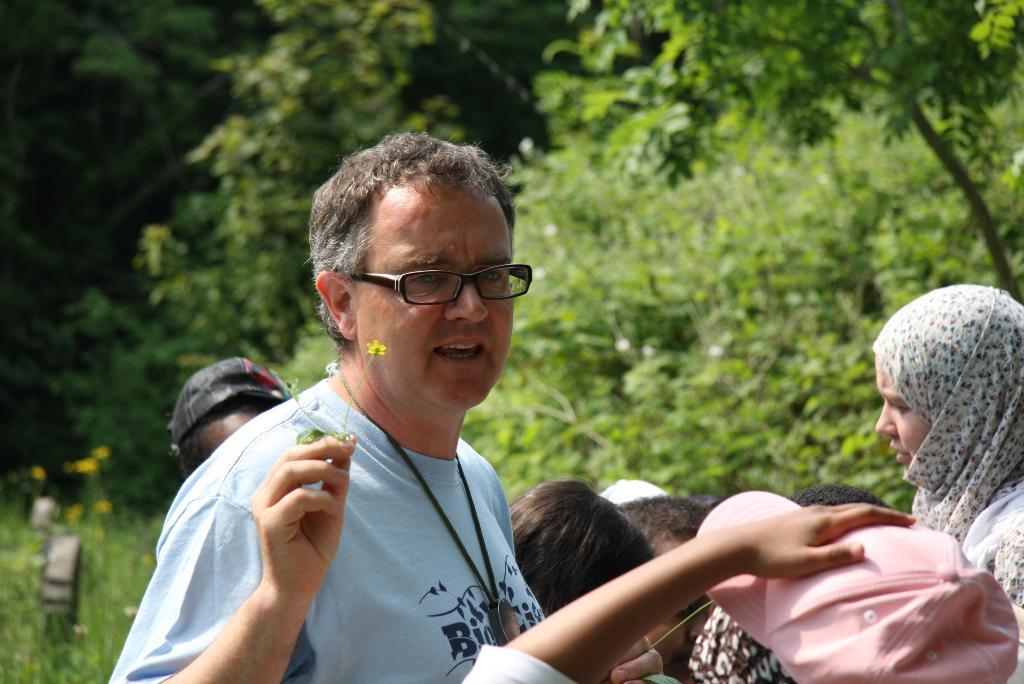What is the man in the image holding? The man is holding small flowers in the image. Can you describe the people on the right side of the image? There are few persons on the right side of the image. What can be seen in the background of the image? There are trees in the background of the image. What type of yoke is being used by the man in the image? There is no yoke present in the image; the man is simply holding small flowers. 